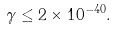Convert formula to latex. <formula><loc_0><loc_0><loc_500><loc_500>\gamma \leq 2 \times 1 0 ^ { - 4 0 } .</formula> 